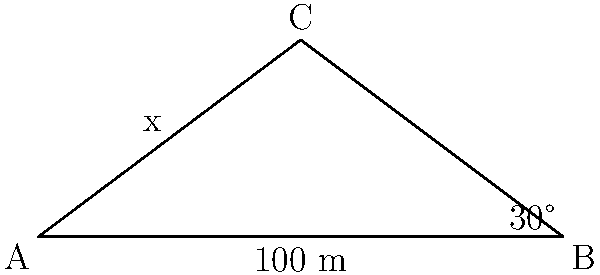As you approach a hidden magical location, you encounter a deep chasm that needs to be crossed with a rope bridge. The chasm forms a right triangle with the following measurements: the width of the chasm is 100 meters, and the angle of elevation to the magical location on the other side is 30°. How long should the rope bridge be to reach the magical location? Let's approach this step-by-step:

1) We can model this scenario as a right triangle, where:
   - The base of the triangle (AB) is the width of the chasm: 100 meters
   - The angle at B is 30°
   - We need to find the length of AC (the hypotenuse), which will be the length of the rope bridge

2) In a right triangle, we can use the trigonometric ratio cosine:

   $\cos \theta = \frac{\text{adjacent}}{\text{hypotenuse}}$

3) In our case:
   $\cos 30° = \frac{100}{x}$, where $x$ is the length of the rope bridge

4) We know that $\cos 30° = \frac{\sqrt{3}}{2}$

5) Substituting this:
   $\frac{\sqrt{3}}{2} = \frac{100}{x}$

6) Cross multiply:
   $x \cdot \frac{\sqrt{3}}{2} = 100$

7) Solve for $x$:
   $x = \frac{100}{\frac{\sqrt{3}}{2}} = \frac{200}{\sqrt{3}}$

8) Simplify:
   $x = \frac{200}{\sqrt{3}} \cdot \frac{\sqrt{3}}{\sqrt{3}} = \frac{200\sqrt{3}}{3} \approx 115.47$ meters

Therefore, the rope bridge should be approximately 115.47 meters long.
Answer: $\frac{200\sqrt{3}}{3}$ meters 